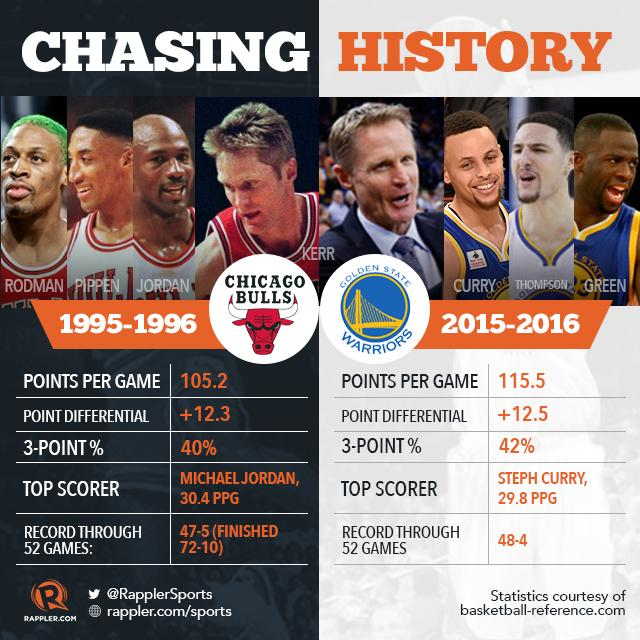Point out several critical features in this image. The Golden State Warriors have made 42% of their three-point shots this season. The person who is making history is Kerr. In the 2016-2017 season, the Chicago Bulls averaged a points per game score of 105.2, demonstrating their impressive offensive prowess and solidifying their position as one of the top scoring teams in the league. The Chicago Bulls have made 3 pointers at a rate of 40%. The Chicago Bulls achieved a point differential of +12.3, demonstrating their dominance on the court. 